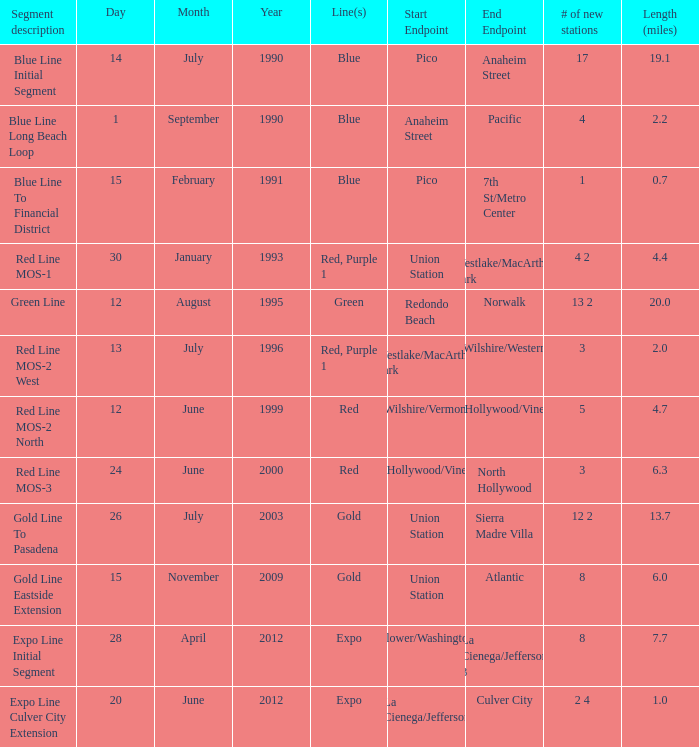How many miles long is the stretch from westlake/macarthur park to wilshire/western? 2.0. 